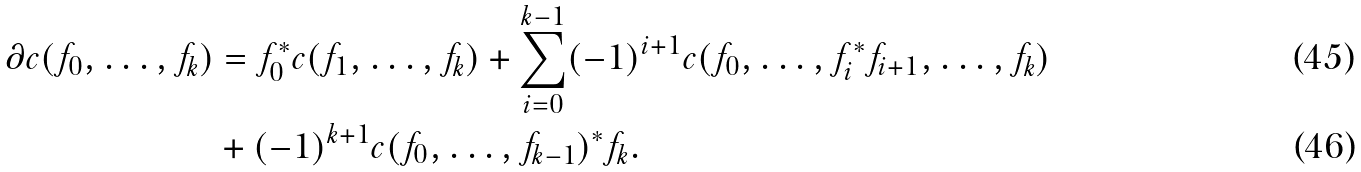Convert formula to latex. <formula><loc_0><loc_0><loc_500><loc_500>\partial c ( f _ { 0 } , \dots , f _ { k } ) & = f _ { 0 } ^ { * } c ( f _ { 1 } , \dots , f _ { k } ) + \sum _ { i = 0 } ^ { k - 1 } ( - 1 ) ^ { i + 1 } c ( f _ { 0 } , \dots , f _ { i } ^ { * } f _ { i + 1 } , \dots , f _ { k } ) \\ & + ( - 1 ) ^ { k + 1 } c ( f _ { 0 } , \dots , f _ { k - 1 } ) ^ { * } f _ { k } .</formula> 